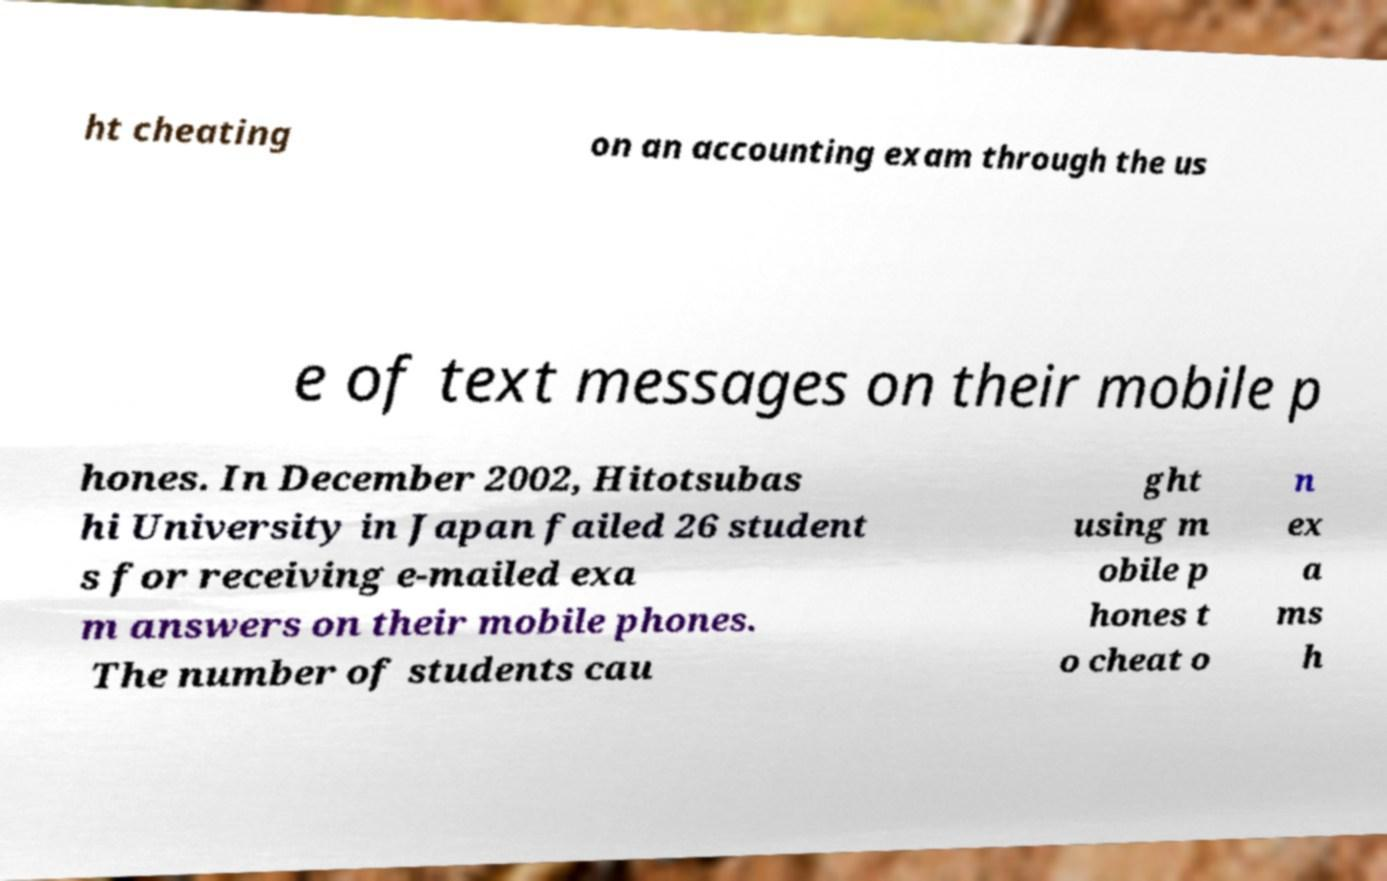I need the written content from this picture converted into text. Can you do that? ht cheating on an accounting exam through the us e of text messages on their mobile p hones. In December 2002, Hitotsubas hi University in Japan failed 26 student s for receiving e-mailed exa m answers on their mobile phones. The number of students cau ght using m obile p hones t o cheat o n ex a ms h 